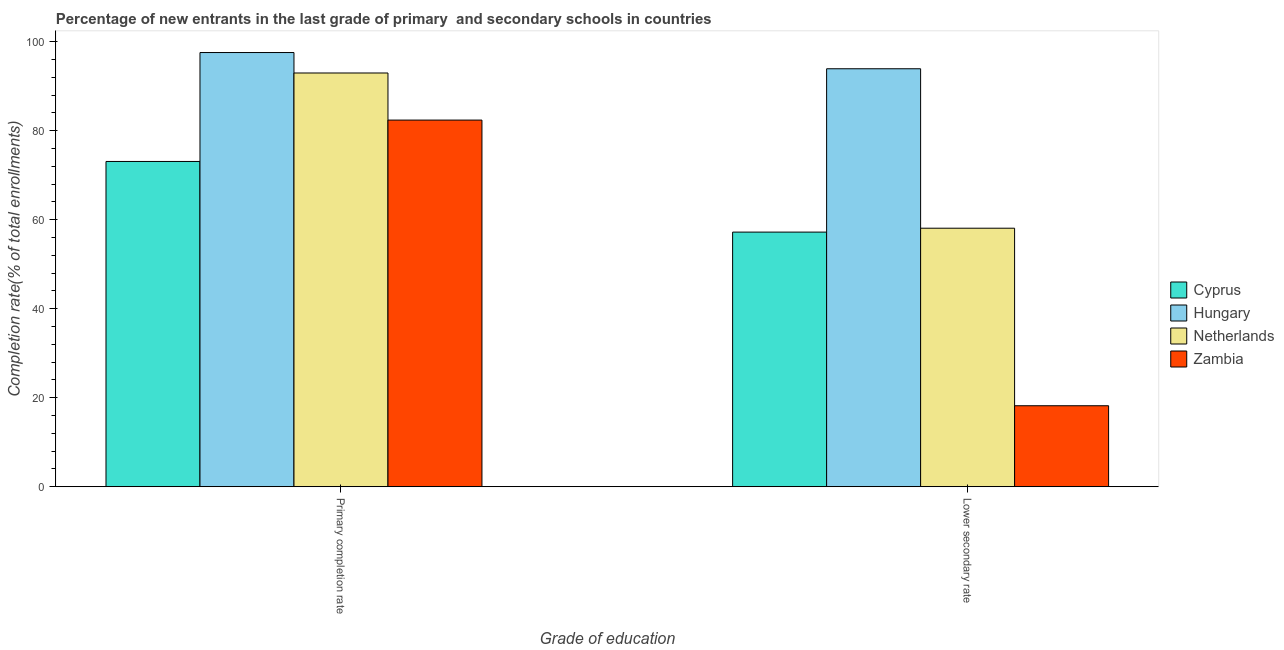How many different coloured bars are there?
Offer a very short reply. 4. Are the number of bars per tick equal to the number of legend labels?
Your answer should be compact. Yes. Are the number of bars on each tick of the X-axis equal?
Offer a terse response. Yes. What is the label of the 2nd group of bars from the left?
Offer a terse response. Lower secondary rate. What is the completion rate in primary schools in Zambia?
Your response must be concise. 82.37. Across all countries, what is the maximum completion rate in secondary schools?
Offer a terse response. 93.9. Across all countries, what is the minimum completion rate in primary schools?
Ensure brevity in your answer.  73.07. In which country was the completion rate in primary schools maximum?
Make the answer very short. Hungary. In which country was the completion rate in secondary schools minimum?
Ensure brevity in your answer.  Zambia. What is the total completion rate in primary schools in the graph?
Provide a short and direct response. 345.93. What is the difference between the completion rate in secondary schools in Netherlands and that in Zambia?
Your answer should be compact. 39.88. What is the difference between the completion rate in secondary schools in Netherlands and the completion rate in primary schools in Cyprus?
Keep it short and to the point. -15. What is the average completion rate in primary schools per country?
Make the answer very short. 86.48. What is the difference between the completion rate in primary schools and completion rate in secondary schools in Hungary?
Offer a very short reply. 3.64. What is the ratio of the completion rate in primary schools in Netherlands to that in Cyprus?
Make the answer very short. 1.27. Is the completion rate in secondary schools in Hungary less than that in Netherlands?
Provide a short and direct response. No. What does the 2nd bar from the left in Primary completion rate represents?
Your response must be concise. Hungary. What does the 3rd bar from the right in Primary completion rate represents?
Keep it short and to the point. Hungary. Are all the bars in the graph horizontal?
Offer a very short reply. No. Are the values on the major ticks of Y-axis written in scientific E-notation?
Ensure brevity in your answer.  No. Does the graph contain any zero values?
Offer a very short reply. No. Where does the legend appear in the graph?
Offer a terse response. Center right. How are the legend labels stacked?
Ensure brevity in your answer.  Vertical. What is the title of the graph?
Make the answer very short. Percentage of new entrants in the last grade of primary  and secondary schools in countries. Does "East Asia (all income levels)" appear as one of the legend labels in the graph?
Offer a very short reply. No. What is the label or title of the X-axis?
Make the answer very short. Grade of education. What is the label or title of the Y-axis?
Ensure brevity in your answer.  Completion rate(% of total enrollments). What is the Completion rate(% of total enrollments) of Cyprus in Primary completion rate?
Offer a terse response. 73.07. What is the Completion rate(% of total enrollments) in Hungary in Primary completion rate?
Offer a very short reply. 97.54. What is the Completion rate(% of total enrollments) in Netherlands in Primary completion rate?
Your response must be concise. 92.95. What is the Completion rate(% of total enrollments) of Zambia in Primary completion rate?
Your answer should be very brief. 82.37. What is the Completion rate(% of total enrollments) in Cyprus in Lower secondary rate?
Offer a very short reply. 57.2. What is the Completion rate(% of total enrollments) in Hungary in Lower secondary rate?
Your response must be concise. 93.9. What is the Completion rate(% of total enrollments) of Netherlands in Lower secondary rate?
Keep it short and to the point. 58.08. What is the Completion rate(% of total enrollments) in Zambia in Lower secondary rate?
Provide a short and direct response. 18.19. Across all Grade of education, what is the maximum Completion rate(% of total enrollments) in Cyprus?
Offer a very short reply. 73.07. Across all Grade of education, what is the maximum Completion rate(% of total enrollments) in Hungary?
Offer a very short reply. 97.54. Across all Grade of education, what is the maximum Completion rate(% of total enrollments) of Netherlands?
Make the answer very short. 92.95. Across all Grade of education, what is the maximum Completion rate(% of total enrollments) of Zambia?
Your response must be concise. 82.37. Across all Grade of education, what is the minimum Completion rate(% of total enrollments) in Cyprus?
Keep it short and to the point. 57.2. Across all Grade of education, what is the minimum Completion rate(% of total enrollments) in Hungary?
Ensure brevity in your answer.  93.9. Across all Grade of education, what is the minimum Completion rate(% of total enrollments) in Netherlands?
Your answer should be compact. 58.08. Across all Grade of education, what is the minimum Completion rate(% of total enrollments) in Zambia?
Offer a very short reply. 18.19. What is the total Completion rate(% of total enrollments) in Cyprus in the graph?
Ensure brevity in your answer.  130.27. What is the total Completion rate(% of total enrollments) in Hungary in the graph?
Keep it short and to the point. 191.44. What is the total Completion rate(% of total enrollments) in Netherlands in the graph?
Ensure brevity in your answer.  151.02. What is the total Completion rate(% of total enrollments) of Zambia in the graph?
Your response must be concise. 100.56. What is the difference between the Completion rate(% of total enrollments) of Cyprus in Primary completion rate and that in Lower secondary rate?
Provide a succinct answer. 15.87. What is the difference between the Completion rate(% of total enrollments) in Hungary in Primary completion rate and that in Lower secondary rate?
Provide a succinct answer. 3.65. What is the difference between the Completion rate(% of total enrollments) of Netherlands in Primary completion rate and that in Lower secondary rate?
Offer a very short reply. 34.87. What is the difference between the Completion rate(% of total enrollments) in Zambia in Primary completion rate and that in Lower secondary rate?
Provide a short and direct response. 64.18. What is the difference between the Completion rate(% of total enrollments) in Cyprus in Primary completion rate and the Completion rate(% of total enrollments) in Hungary in Lower secondary rate?
Your answer should be compact. -20.83. What is the difference between the Completion rate(% of total enrollments) of Cyprus in Primary completion rate and the Completion rate(% of total enrollments) of Netherlands in Lower secondary rate?
Make the answer very short. 15. What is the difference between the Completion rate(% of total enrollments) of Cyprus in Primary completion rate and the Completion rate(% of total enrollments) of Zambia in Lower secondary rate?
Provide a short and direct response. 54.88. What is the difference between the Completion rate(% of total enrollments) in Hungary in Primary completion rate and the Completion rate(% of total enrollments) in Netherlands in Lower secondary rate?
Offer a very short reply. 39.47. What is the difference between the Completion rate(% of total enrollments) in Hungary in Primary completion rate and the Completion rate(% of total enrollments) in Zambia in Lower secondary rate?
Give a very brief answer. 79.35. What is the difference between the Completion rate(% of total enrollments) in Netherlands in Primary completion rate and the Completion rate(% of total enrollments) in Zambia in Lower secondary rate?
Offer a very short reply. 74.76. What is the average Completion rate(% of total enrollments) of Cyprus per Grade of education?
Your response must be concise. 65.14. What is the average Completion rate(% of total enrollments) in Hungary per Grade of education?
Your response must be concise. 95.72. What is the average Completion rate(% of total enrollments) of Netherlands per Grade of education?
Offer a terse response. 75.51. What is the average Completion rate(% of total enrollments) in Zambia per Grade of education?
Your answer should be very brief. 50.28. What is the difference between the Completion rate(% of total enrollments) of Cyprus and Completion rate(% of total enrollments) of Hungary in Primary completion rate?
Provide a succinct answer. -24.47. What is the difference between the Completion rate(% of total enrollments) in Cyprus and Completion rate(% of total enrollments) in Netherlands in Primary completion rate?
Keep it short and to the point. -19.88. What is the difference between the Completion rate(% of total enrollments) in Cyprus and Completion rate(% of total enrollments) in Zambia in Primary completion rate?
Provide a succinct answer. -9.29. What is the difference between the Completion rate(% of total enrollments) in Hungary and Completion rate(% of total enrollments) in Netherlands in Primary completion rate?
Ensure brevity in your answer.  4.6. What is the difference between the Completion rate(% of total enrollments) of Hungary and Completion rate(% of total enrollments) of Zambia in Primary completion rate?
Your answer should be compact. 15.18. What is the difference between the Completion rate(% of total enrollments) in Netherlands and Completion rate(% of total enrollments) in Zambia in Primary completion rate?
Your answer should be compact. 10.58. What is the difference between the Completion rate(% of total enrollments) of Cyprus and Completion rate(% of total enrollments) of Hungary in Lower secondary rate?
Provide a succinct answer. -36.7. What is the difference between the Completion rate(% of total enrollments) of Cyprus and Completion rate(% of total enrollments) of Netherlands in Lower secondary rate?
Your answer should be compact. -0.87. What is the difference between the Completion rate(% of total enrollments) of Cyprus and Completion rate(% of total enrollments) of Zambia in Lower secondary rate?
Your answer should be very brief. 39.01. What is the difference between the Completion rate(% of total enrollments) in Hungary and Completion rate(% of total enrollments) in Netherlands in Lower secondary rate?
Your response must be concise. 35.82. What is the difference between the Completion rate(% of total enrollments) in Hungary and Completion rate(% of total enrollments) in Zambia in Lower secondary rate?
Give a very brief answer. 75.71. What is the difference between the Completion rate(% of total enrollments) of Netherlands and Completion rate(% of total enrollments) of Zambia in Lower secondary rate?
Give a very brief answer. 39.88. What is the ratio of the Completion rate(% of total enrollments) in Cyprus in Primary completion rate to that in Lower secondary rate?
Offer a very short reply. 1.28. What is the ratio of the Completion rate(% of total enrollments) of Hungary in Primary completion rate to that in Lower secondary rate?
Your response must be concise. 1.04. What is the ratio of the Completion rate(% of total enrollments) of Netherlands in Primary completion rate to that in Lower secondary rate?
Provide a short and direct response. 1.6. What is the ratio of the Completion rate(% of total enrollments) of Zambia in Primary completion rate to that in Lower secondary rate?
Make the answer very short. 4.53. What is the difference between the highest and the second highest Completion rate(% of total enrollments) of Cyprus?
Your response must be concise. 15.87. What is the difference between the highest and the second highest Completion rate(% of total enrollments) in Hungary?
Provide a succinct answer. 3.65. What is the difference between the highest and the second highest Completion rate(% of total enrollments) in Netherlands?
Keep it short and to the point. 34.87. What is the difference between the highest and the second highest Completion rate(% of total enrollments) in Zambia?
Provide a short and direct response. 64.18. What is the difference between the highest and the lowest Completion rate(% of total enrollments) in Cyprus?
Offer a terse response. 15.87. What is the difference between the highest and the lowest Completion rate(% of total enrollments) of Hungary?
Your answer should be compact. 3.65. What is the difference between the highest and the lowest Completion rate(% of total enrollments) of Netherlands?
Offer a very short reply. 34.87. What is the difference between the highest and the lowest Completion rate(% of total enrollments) of Zambia?
Your answer should be very brief. 64.18. 